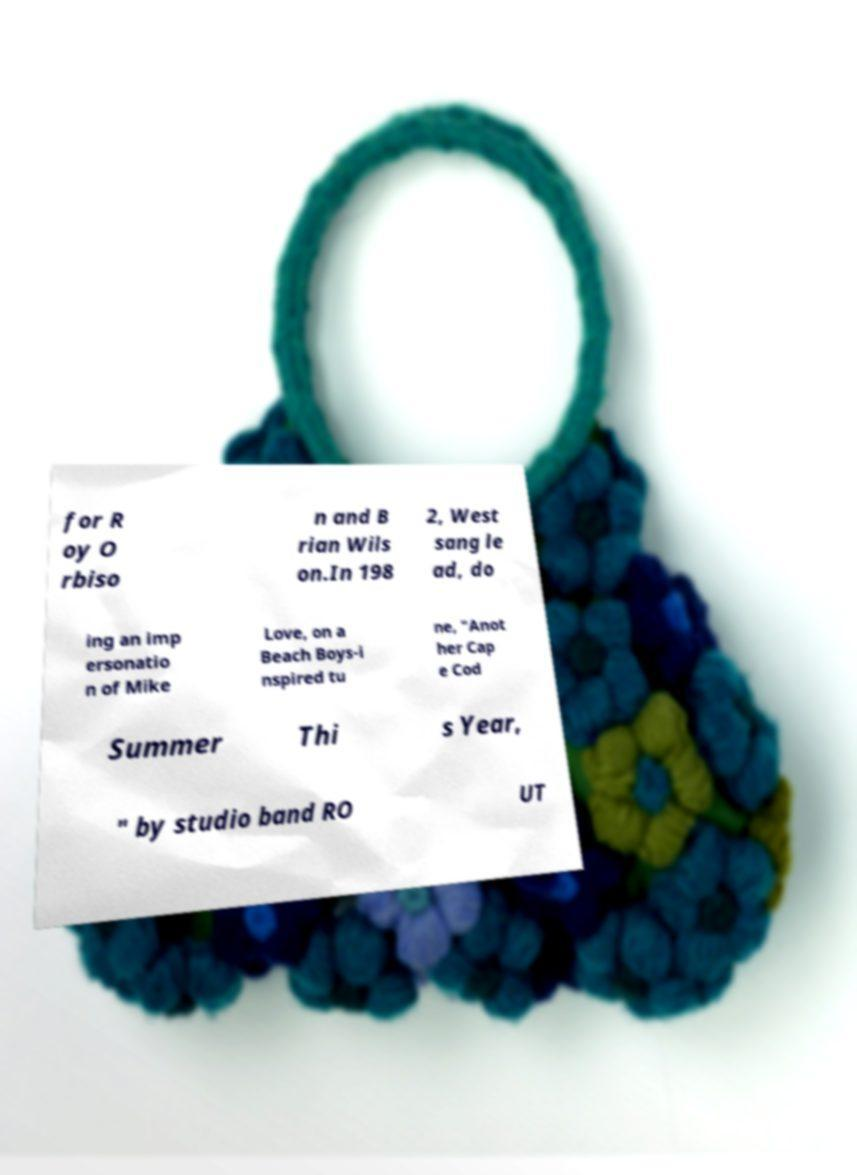Could you extract and type out the text from this image? for R oy O rbiso n and B rian Wils on.In 198 2, West sang le ad, do ing an imp ersonatio n of Mike Love, on a Beach Boys-i nspired tu ne, "Anot her Cap e Cod Summer Thi s Year, " by studio band RO UT 